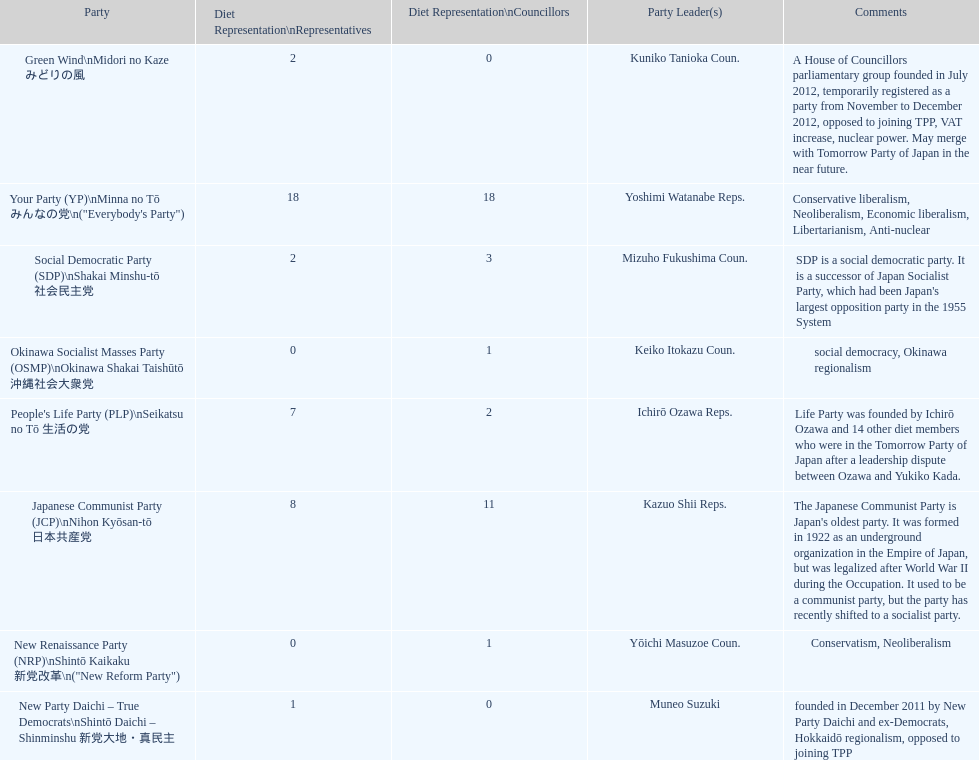How many of these parties currently have no councillors? 2. 